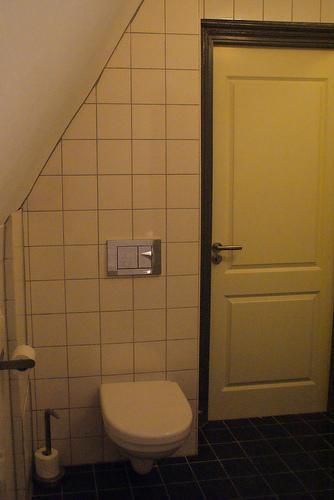How many people in the toilet?
Give a very brief answer. 0. 